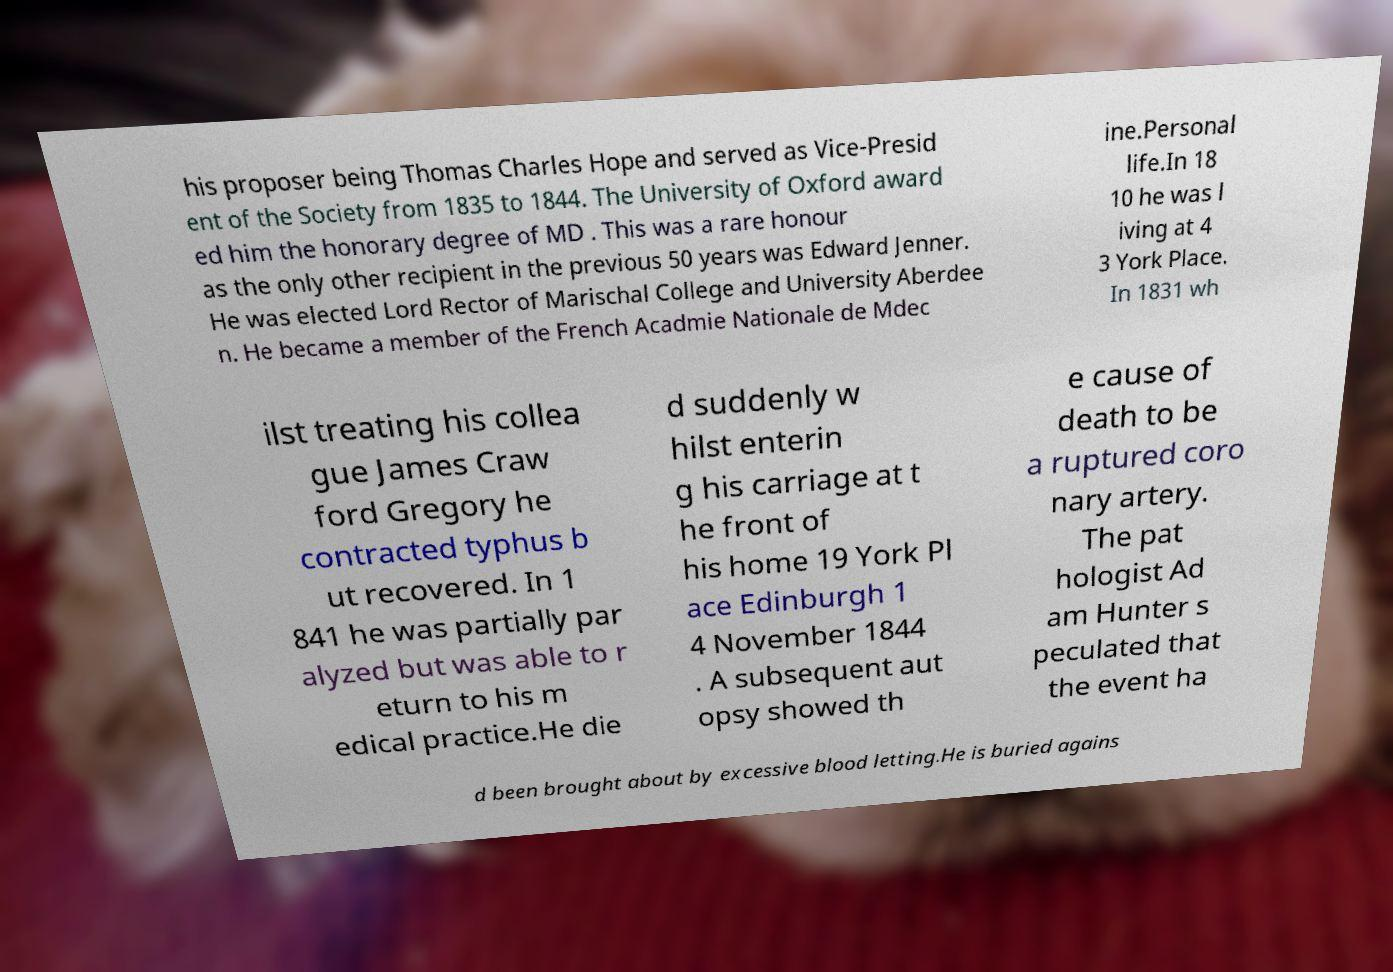There's text embedded in this image that I need extracted. Can you transcribe it verbatim? his proposer being Thomas Charles Hope and served as Vice-Presid ent of the Society from 1835 to 1844. The University of Oxford award ed him the honorary degree of MD . This was a rare honour as the only other recipient in the previous 50 years was Edward Jenner. He was elected Lord Rector of Marischal College and University Aberdee n. He became a member of the French Acadmie Nationale de Mdec ine.Personal life.In 18 10 he was l iving at 4 3 York Place. In 1831 wh ilst treating his collea gue James Craw ford Gregory he contracted typhus b ut recovered. In 1 841 he was partially par alyzed but was able to r eturn to his m edical practice.He die d suddenly w hilst enterin g his carriage at t he front of his home 19 York Pl ace Edinburgh 1 4 November 1844 . A subsequent aut opsy showed th e cause of death to be a ruptured coro nary artery. The pat hologist Ad am Hunter s peculated that the event ha d been brought about by excessive blood letting.He is buried agains 